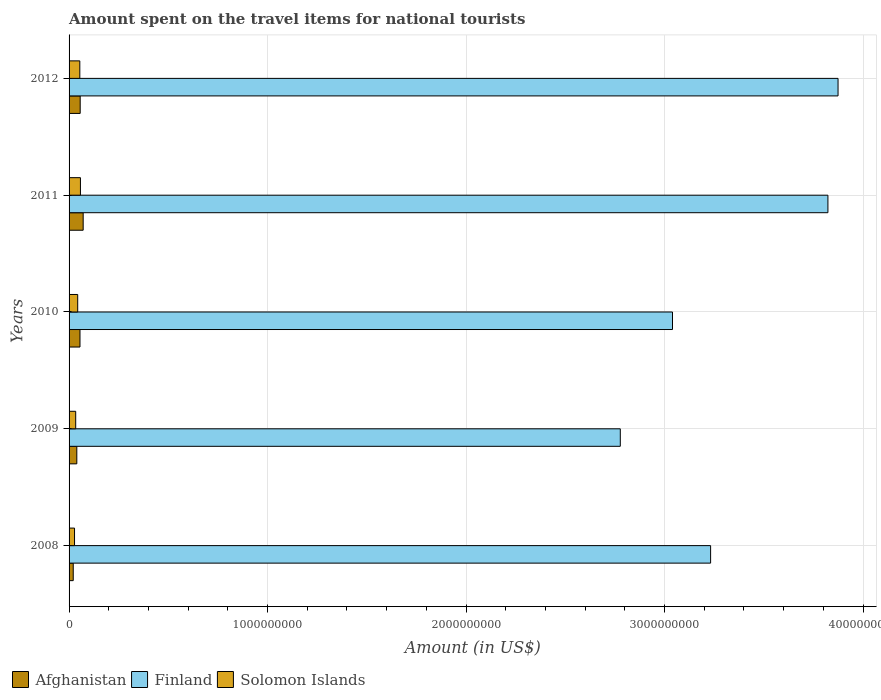Are the number of bars per tick equal to the number of legend labels?
Make the answer very short. Yes. How many bars are there on the 3rd tick from the bottom?
Your answer should be very brief. 3. What is the label of the 5th group of bars from the top?
Your response must be concise. 2008. What is the amount spent on the travel items for national tourists in Solomon Islands in 2010?
Offer a terse response. 4.35e+07. Across all years, what is the maximum amount spent on the travel items for national tourists in Finland?
Provide a short and direct response. 3.87e+09. Across all years, what is the minimum amount spent on the travel items for national tourists in Finland?
Provide a succinct answer. 2.78e+09. In which year was the amount spent on the travel items for national tourists in Solomon Islands maximum?
Your answer should be compact. 2011. What is the total amount spent on the travel items for national tourists in Solomon Islands in the graph?
Your answer should be compact. 2.16e+08. What is the difference between the amount spent on the travel items for national tourists in Afghanistan in 2011 and that in 2012?
Ensure brevity in your answer.  1.50e+07. What is the difference between the amount spent on the travel items for national tourists in Finland in 2009 and the amount spent on the travel items for national tourists in Afghanistan in 2012?
Offer a very short reply. 2.72e+09. What is the average amount spent on the travel items for national tourists in Afghanistan per year?
Give a very brief answer. 4.84e+07. In the year 2008, what is the difference between the amount spent on the travel items for national tourists in Finland and amount spent on the travel items for national tourists in Solomon Islands?
Provide a short and direct response. 3.20e+09. What is the ratio of the amount spent on the travel items for national tourists in Afghanistan in 2011 to that in 2012?
Offer a terse response. 1.27. Is the amount spent on the travel items for national tourists in Finland in 2009 less than that in 2010?
Provide a succinct answer. Yes. What is the difference between the highest and the second highest amount spent on the travel items for national tourists in Finland?
Make the answer very short. 5.10e+07. What is the difference between the highest and the lowest amount spent on the travel items for national tourists in Solomon Islands?
Give a very brief answer. 2.98e+07. Is the sum of the amount spent on the travel items for national tourists in Afghanistan in 2009 and 2012 greater than the maximum amount spent on the travel items for national tourists in Solomon Islands across all years?
Provide a succinct answer. Yes. What does the 1st bar from the top in 2011 represents?
Give a very brief answer. Solomon Islands. What does the 3rd bar from the bottom in 2009 represents?
Keep it short and to the point. Solomon Islands. Is it the case that in every year, the sum of the amount spent on the travel items for national tourists in Solomon Islands and amount spent on the travel items for national tourists in Afghanistan is greater than the amount spent on the travel items for national tourists in Finland?
Your answer should be very brief. No. How many years are there in the graph?
Provide a short and direct response. 5. Where does the legend appear in the graph?
Your answer should be compact. Bottom left. How many legend labels are there?
Your response must be concise. 3. What is the title of the graph?
Provide a succinct answer. Amount spent on the travel items for national tourists. What is the label or title of the X-axis?
Offer a very short reply. Amount (in US$). What is the Amount (in US$) of Afghanistan in 2008?
Your answer should be compact. 2.10e+07. What is the Amount (in US$) in Finland in 2008?
Offer a terse response. 3.23e+09. What is the Amount (in US$) of Solomon Islands in 2008?
Your response must be concise. 2.75e+07. What is the Amount (in US$) of Afghanistan in 2009?
Keep it short and to the point. 3.90e+07. What is the Amount (in US$) in Finland in 2009?
Keep it short and to the point. 2.78e+09. What is the Amount (in US$) in Solomon Islands in 2009?
Give a very brief answer. 3.34e+07. What is the Amount (in US$) in Afghanistan in 2010?
Provide a short and direct response. 5.50e+07. What is the Amount (in US$) in Finland in 2010?
Provide a succinct answer. 3.04e+09. What is the Amount (in US$) in Solomon Islands in 2010?
Keep it short and to the point. 4.35e+07. What is the Amount (in US$) of Afghanistan in 2011?
Provide a succinct answer. 7.10e+07. What is the Amount (in US$) of Finland in 2011?
Your answer should be compact. 3.82e+09. What is the Amount (in US$) of Solomon Islands in 2011?
Give a very brief answer. 5.73e+07. What is the Amount (in US$) of Afghanistan in 2012?
Offer a very short reply. 5.60e+07. What is the Amount (in US$) in Finland in 2012?
Ensure brevity in your answer.  3.87e+09. What is the Amount (in US$) in Solomon Islands in 2012?
Ensure brevity in your answer.  5.41e+07. Across all years, what is the maximum Amount (in US$) of Afghanistan?
Your answer should be compact. 7.10e+07. Across all years, what is the maximum Amount (in US$) in Finland?
Offer a terse response. 3.87e+09. Across all years, what is the maximum Amount (in US$) in Solomon Islands?
Offer a terse response. 5.73e+07. Across all years, what is the minimum Amount (in US$) in Afghanistan?
Your answer should be compact. 2.10e+07. Across all years, what is the minimum Amount (in US$) in Finland?
Give a very brief answer. 2.78e+09. Across all years, what is the minimum Amount (in US$) of Solomon Islands?
Ensure brevity in your answer.  2.75e+07. What is the total Amount (in US$) of Afghanistan in the graph?
Give a very brief answer. 2.42e+08. What is the total Amount (in US$) of Finland in the graph?
Provide a succinct answer. 1.67e+1. What is the total Amount (in US$) in Solomon Islands in the graph?
Offer a terse response. 2.16e+08. What is the difference between the Amount (in US$) in Afghanistan in 2008 and that in 2009?
Ensure brevity in your answer.  -1.80e+07. What is the difference between the Amount (in US$) in Finland in 2008 and that in 2009?
Your answer should be very brief. 4.55e+08. What is the difference between the Amount (in US$) in Solomon Islands in 2008 and that in 2009?
Provide a short and direct response. -5.90e+06. What is the difference between the Amount (in US$) of Afghanistan in 2008 and that in 2010?
Ensure brevity in your answer.  -3.40e+07. What is the difference between the Amount (in US$) of Finland in 2008 and that in 2010?
Offer a terse response. 1.92e+08. What is the difference between the Amount (in US$) in Solomon Islands in 2008 and that in 2010?
Offer a very short reply. -1.60e+07. What is the difference between the Amount (in US$) of Afghanistan in 2008 and that in 2011?
Offer a terse response. -5.00e+07. What is the difference between the Amount (in US$) in Finland in 2008 and that in 2011?
Ensure brevity in your answer.  -5.91e+08. What is the difference between the Amount (in US$) in Solomon Islands in 2008 and that in 2011?
Your answer should be compact. -2.98e+07. What is the difference between the Amount (in US$) of Afghanistan in 2008 and that in 2012?
Ensure brevity in your answer.  -3.50e+07. What is the difference between the Amount (in US$) of Finland in 2008 and that in 2012?
Ensure brevity in your answer.  -6.42e+08. What is the difference between the Amount (in US$) in Solomon Islands in 2008 and that in 2012?
Your answer should be very brief. -2.66e+07. What is the difference between the Amount (in US$) of Afghanistan in 2009 and that in 2010?
Offer a terse response. -1.60e+07. What is the difference between the Amount (in US$) in Finland in 2009 and that in 2010?
Offer a terse response. -2.63e+08. What is the difference between the Amount (in US$) in Solomon Islands in 2009 and that in 2010?
Your response must be concise. -1.01e+07. What is the difference between the Amount (in US$) in Afghanistan in 2009 and that in 2011?
Your answer should be compact. -3.20e+07. What is the difference between the Amount (in US$) of Finland in 2009 and that in 2011?
Offer a very short reply. -1.05e+09. What is the difference between the Amount (in US$) of Solomon Islands in 2009 and that in 2011?
Provide a short and direct response. -2.39e+07. What is the difference between the Amount (in US$) in Afghanistan in 2009 and that in 2012?
Your answer should be very brief. -1.70e+07. What is the difference between the Amount (in US$) of Finland in 2009 and that in 2012?
Your response must be concise. -1.10e+09. What is the difference between the Amount (in US$) in Solomon Islands in 2009 and that in 2012?
Your answer should be very brief. -2.07e+07. What is the difference between the Amount (in US$) in Afghanistan in 2010 and that in 2011?
Ensure brevity in your answer.  -1.60e+07. What is the difference between the Amount (in US$) in Finland in 2010 and that in 2011?
Provide a succinct answer. -7.83e+08. What is the difference between the Amount (in US$) in Solomon Islands in 2010 and that in 2011?
Your answer should be compact. -1.38e+07. What is the difference between the Amount (in US$) of Finland in 2010 and that in 2012?
Offer a terse response. -8.34e+08. What is the difference between the Amount (in US$) in Solomon Islands in 2010 and that in 2012?
Give a very brief answer. -1.06e+07. What is the difference between the Amount (in US$) of Afghanistan in 2011 and that in 2012?
Your answer should be very brief. 1.50e+07. What is the difference between the Amount (in US$) of Finland in 2011 and that in 2012?
Make the answer very short. -5.10e+07. What is the difference between the Amount (in US$) in Solomon Islands in 2011 and that in 2012?
Your answer should be very brief. 3.20e+06. What is the difference between the Amount (in US$) of Afghanistan in 2008 and the Amount (in US$) of Finland in 2009?
Give a very brief answer. -2.76e+09. What is the difference between the Amount (in US$) in Afghanistan in 2008 and the Amount (in US$) in Solomon Islands in 2009?
Provide a succinct answer. -1.24e+07. What is the difference between the Amount (in US$) of Finland in 2008 and the Amount (in US$) of Solomon Islands in 2009?
Make the answer very short. 3.20e+09. What is the difference between the Amount (in US$) of Afghanistan in 2008 and the Amount (in US$) of Finland in 2010?
Your answer should be compact. -3.02e+09. What is the difference between the Amount (in US$) of Afghanistan in 2008 and the Amount (in US$) of Solomon Islands in 2010?
Your answer should be compact. -2.25e+07. What is the difference between the Amount (in US$) in Finland in 2008 and the Amount (in US$) in Solomon Islands in 2010?
Offer a very short reply. 3.19e+09. What is the difference between the Amount (in US$) of Afghanistan in 2008 and the Amount (in US$) of Finland in 2011?
Your answer should be compact. -3.80e+09. What is the difference between the Amount (in US$) of Afghanistan in 2008 and the Amount (in US$) of Solomon Islands in 2011?
Provide a succinct answer. -3.63e+07. What is the difference between the Amount (in US$) of Finland in 2008 and the Amount (in US$) of Solomon Islands in 2011?
Make the answer very short. 3.17e+09. What is the difference between the Amount (in US$) of Afghanistan in 2008 and the Amount (in US$) of Finland in 2012?
Keep it short and to the point. -3.85e+09. What is the difference between the Amount (in US$) in Afghanistan in 2008 and the Amount (in US$) in Solomon Islands in 2012?
Offer a very short reply. -3.31e+07. What is the difference between the Amount (in US$) of Finland in 2008 and the Amount (in US$) of Solomon Islands in 2012?
Offer a very short reply. 3.18e+09. What is the difference between the Amount (in US$) of Afghanistan in 2009 and the Amount (in US$) of Finland in 2010?
Your answer should be compact. -3.00e+09. What is the difference between the Amount (in US$) in Afghanistan in 2009 and the Amount (in US$) in Solomon Islands in 2010?
Your answer should be very brief. -4.50e+06. What is the difference between the Amount (in US$) of Finland in 2009 and the Amount (in US$) of Solomon Islands in 2010?
Ensure brevity in your answer.  2.73e+09. What is the difference between the Amount (in US$) in Afghanistan in 2009 and the Amount (in US$) in Finland in 2011?
Make the answer very short. -3.78e+09. What is the difference between the Amount (in US$) in Afghanistan in 2009 and the Amount (in US$) in Solomon Islands in 2011?
Provide a succinct answer. -1.83e+07. What is the difference between the Amount (in US$) in Finland in 2009 and the Amount (in US$) in Solomon Islands in 2011?
Your response must be concise. 2.72e+09. What is the difference between the Amount (in US$) in Afghanistan in 2009 and the Amount (in US$) in Finland in 2012?
Keep it short and to the point. -3.84e+09. What is the difference between the Amount (in US$) in Afghanistan in 2009 and the Amount (in US$) in Solomon Islands in 2012?
Offer a very short reply. -1.51e+07. What is the difference between the Amount (in US$) in Finland in 2009 and the Amount (in US$) in Solomon Islands in 2012?
Offer a terse response. 2.72e+09. What is the difference between the Amount (in US$) of Afghanistan in 2010 and the Amount (in US$) of Finland in 2011?
Provide a succinct answer. -3.77e+09. What is the difference between the Amount (in US$) of Afghanistan in 2010 and the Amount (in US$) of Solomon Islands in 2011?
Make the answer very short. -2.30e+06. What is the difference between the Amount (in US$) of Finland in 2010 and the Amount (in US$) of Solomon Islands in 2011?
Make the answer very short. 2.98e+09. What is the difference between the Amount (in US$) of Afghanistan in 2010 and the Amount (in US$) of Finland in 2012?
Your response must be concise. -3.82e+09. What is the difference between the Amount (in US$) of Afghanistan in 2010 and the Amount (in US$) of Solomon Islands in 2012?
Keep it short and to the point. 9.00e+05. What is the difference between the Amount (in US$) in Finland in 2010 and the Amount (in US$) in Solomon Islands in 2012?
Your answer should be compact. 2.99e+09. What is the difference between the Amount (in US$) of Afghanistan in 2011 and the Amount (in US$) of Finland in 2012?
Offer a very short reply. -3.80e+09. What is the difference between the Amount (in US$) in Afghanistan in 2011 and the Amount (in US$) in Solomon Islands in 2012?
Provide a succinct answer. 1.69e+07. What is the difference between the Amount (in US$) of Finland in 2011 and the Amount (in US$) of Solomon Islands in 2012?
Your response must be concise. 3.77e+09. What is the average Amount (in US$) of Afghanistan per year?
Keep it short and to the point. 4.84e+07. What is the average Amount (in US$) of Finland per year?
Offer a very short reply. 3.35e+09. What is the average Amount (in US$) of Solomon Islands per year?
Ensure brevity in your answer.  4.32e+07. In the year 2008, what is the difference between the Amount (in US$) of Afghanistan and Amount (in US$) of Finland?
Ensure brevity in your answer.  -3.21e+09. In the year 2008, what is the difference between the Amount (in US$) in Afghanistan and Amount (in US$) in Solomon Islands?
Make the answer very short. -6.50e+06. In the year 2008, what is the difference between the Amount (in US$) of Finland and Amount (in US$) of Solomon Islands?
Keep it short and to the point. 3.20e+09. In the year 2009, what is the difference between the Amount (in US$) of Afghanistan and Amount (in US$) of Finland?
Provide a succinct answer. -2.74e+09. In the year 2009, what is the difference between the Amount (in US$) of Afghanistan and Amount (in US$) of Solomon Islands?
Keep it short and to the point. 5.60e+06. In the year 2009, what is the difference between the Amount (in US$) in Finland and Amount (in US$) in Solomon Islands?
Keep it short and to the point. 2.74e+09. In the year 2010, what is the difference between the Amount (in US$) in Afghanistan and Amount (in US$) in Finland?
Your response must be concise. -2.98e+09. In the year 2010, what is the difference between the Amount (in US$) in Afghanistan and Amount (in US$) in Solomon Islands?
Keep it short and to the point. 1.15e+07. In the year 2010, what is the difference between the Amount (in US$) of Finland and Amount (in US$) of Solomon Islands?
Offer a very short reply. 3.00e+09. In the year 2011, what is the difference between the Amount (in US$) of Afghanistan and Amount (in US$) of Finland?
Offer a very short reply. -3.75e+09. In the year 2011, what is the difference between the Amount (in US$) of Afghanistan and Amount (in US$) of Solomon Islands?
Offer a very short reply. 1.37e+07. In the year 2011, what is the difference between the Amount (in US$) of Finland and Amount (in US$) of Solomon Islands?
Keep it short and to the point. 3.77e+09. In the year 2012, what is the difference between the Amount (in US$) in Afghanistan and Amount (in US$) in Finland?
Make the answer very short. -3.82e+09. In the year 2012, what is the difference between the Amount (in US$) in Afghanistan and Amount (in US$) in Solomon Islands?
Provide a succinct answer. 1.90e+06. In the year 2012, what is the difference between the Amount (in US$) in Finland and Amount (in US$) in Solomon Islands?
Provide a succinct answer. 3.82e+09. What is the ratio of the Amount (in US$) in Afghanistan in 2008 to that in 2009?
Your answer should be compact. 0.54. What is the ratio of the Amount (in US$) of Finland in 2008 to that in 2009?
Make the answer very short. 1.16. What is the ratio of the Amount (in US$) in Solomon Islands in 2008 to that in 2009?
Keep it short and to the point. 0.82. What is the ratio of the Amount (in US$) in Afghanistan in 2008 to that in 2010?
Offer a very short reply. 0.38. What is the ratio of the Amount (in US$) of Finland in 2008 to that in 2010?
Your answer should be very brief. 1.06. What is the ratio of the Amount (in US$) of Solomon Islands in 2008 to that in 2010?
Ensure brevity in your answer.  0.63. What is the ratio of the Amount (in US$) of Afghanistan in 2008 to that in 2011?
Provide a short and direct response. 0.3. What is the ratio of the Amount (in US$) in Finland in 2008 to that in 2011?
Ensure brevity in your answer.  0.85. What is the ratio of the Amount (in US$) in Solomon Islands in 2008 to that in 2011?
Your response must be concise. 0.48. What is the ratio of the Amount (in US$) of Finland in 2008 to that in 2012?
Ensure brevity in your answer.  0.83. What is the ratio of the Amount (in US$) in Solomon Islands in 2008 to that in 2012?
Offer a terse response. 0.51. What is the ratio of the Amount (in US$) of Afghanistan in 2009 to that in 2010?
Provide a short and direct response. 0.71. What is the ratio of the Amount (in US$) of Finland in 2009 to that in 2010?
Your answer should be very brief. 0.91. What is the ratio of the Amount (in US$) in Solomon Islands in 2009 to that in 2010?
Ensure brevity in your answer.  0.77. What is the ratio of the Amount (in US$) in Afghanistan in 2009 to that in 2011?
Ensure brevity in your answer.  0.55. What is the ratio of the Amount (in US$) in Finland in 2009 to that in 2011?
Keep it short and to the point. 0.73. What is the ratio of the Amount (in US$) of Solomon Islands in 2009 to that in 2011?
Keep it short and to the point. 0.58. What is the ratio of the Amount (in US$) of Afghanistan in 2009 to that in 2012?
Offer a very short reply. 0.7. What is the ratio of the Amount (in US$) of Finland in 2009 to that in 2012?
Give a very brief answer. 0.72. What is the ratio of the Amount (in US$) of Solomon Islands in 2009 to that in 2012?
Provide a short and direct response. 0.62. What is the ratio of the Amount (in US$) of Afghanistan in 2010 to that in 2011?
Make the answer very short. 0.77. What is the ratio of the Amount (in US$) in Finland in 2010 to that in 2011?
Ensure brevity in your answer.  0.8. What is the ratio of the Amount (in US$) of Solomon Islands in 2010 to that in 2011?
Offer a terse response. 0.76. What is the ratio of the Amount (in US$) of Afghanistan in 2010 to that in 2012?
Ensure brevity in your answer.  0.98. What is the ratio of the Amount (in US$) of Finland in 2010 to that in 2012?
Provide a short and direct response. 0.78. What is the ratio of the Amount (in US$) of Solomon Islands in 2010 to that in 2012?
Offer a terse response. 0.8. What is the ratio of the Amount (in US$) in Afghanistan in 2011 to that in 2012?
Your answer should be very brief. 1.27. What is the ratio of the Amount (in US$) in Solomon Islands in 2011 to that in 2012?
Keep it short and to the point. 1.06. What is the difference between the highest and the second highest Amount (in US$) of Afghanistan?
Offer a terse response. 1.50e+07. What is the difference between the highest and the second highest Amount (in US$) in Finland?
Provide a succinct answer. 5.10e+07. What is the difference between the highest and the second highest Amount (in US$) in Solomon Islands?
Offer a terse response. 3.20e+06. What is the difference between the highest and the lowest Amount (in US$) of Finland?
Make the answer very short. 1.10e+09. What is the difference between the highest and the lowest Amount (in US$) in Solomon Islands?
Give a very brief answer. 2.98e+07. 